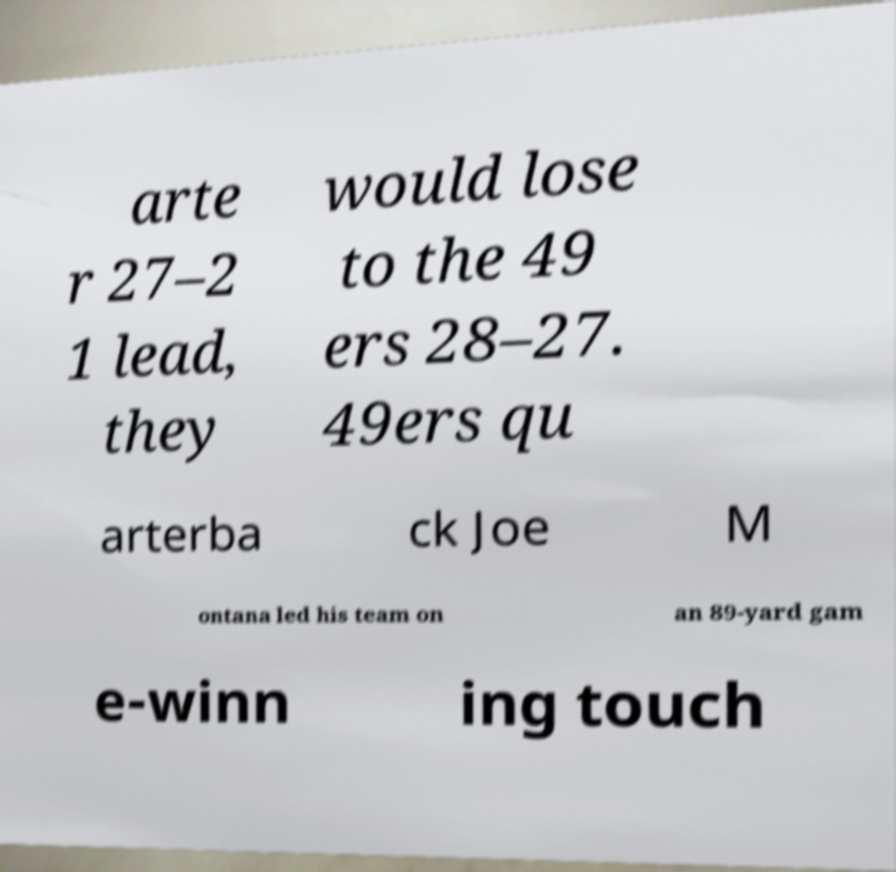Please identify and transcribe the text found in this image. arte r 27–2 1 lead, they would lose to the 49 ers 28–27. 49ers qu arterba ck Joe M ontana led his team on an 89-yard gam e-winn ing touch 